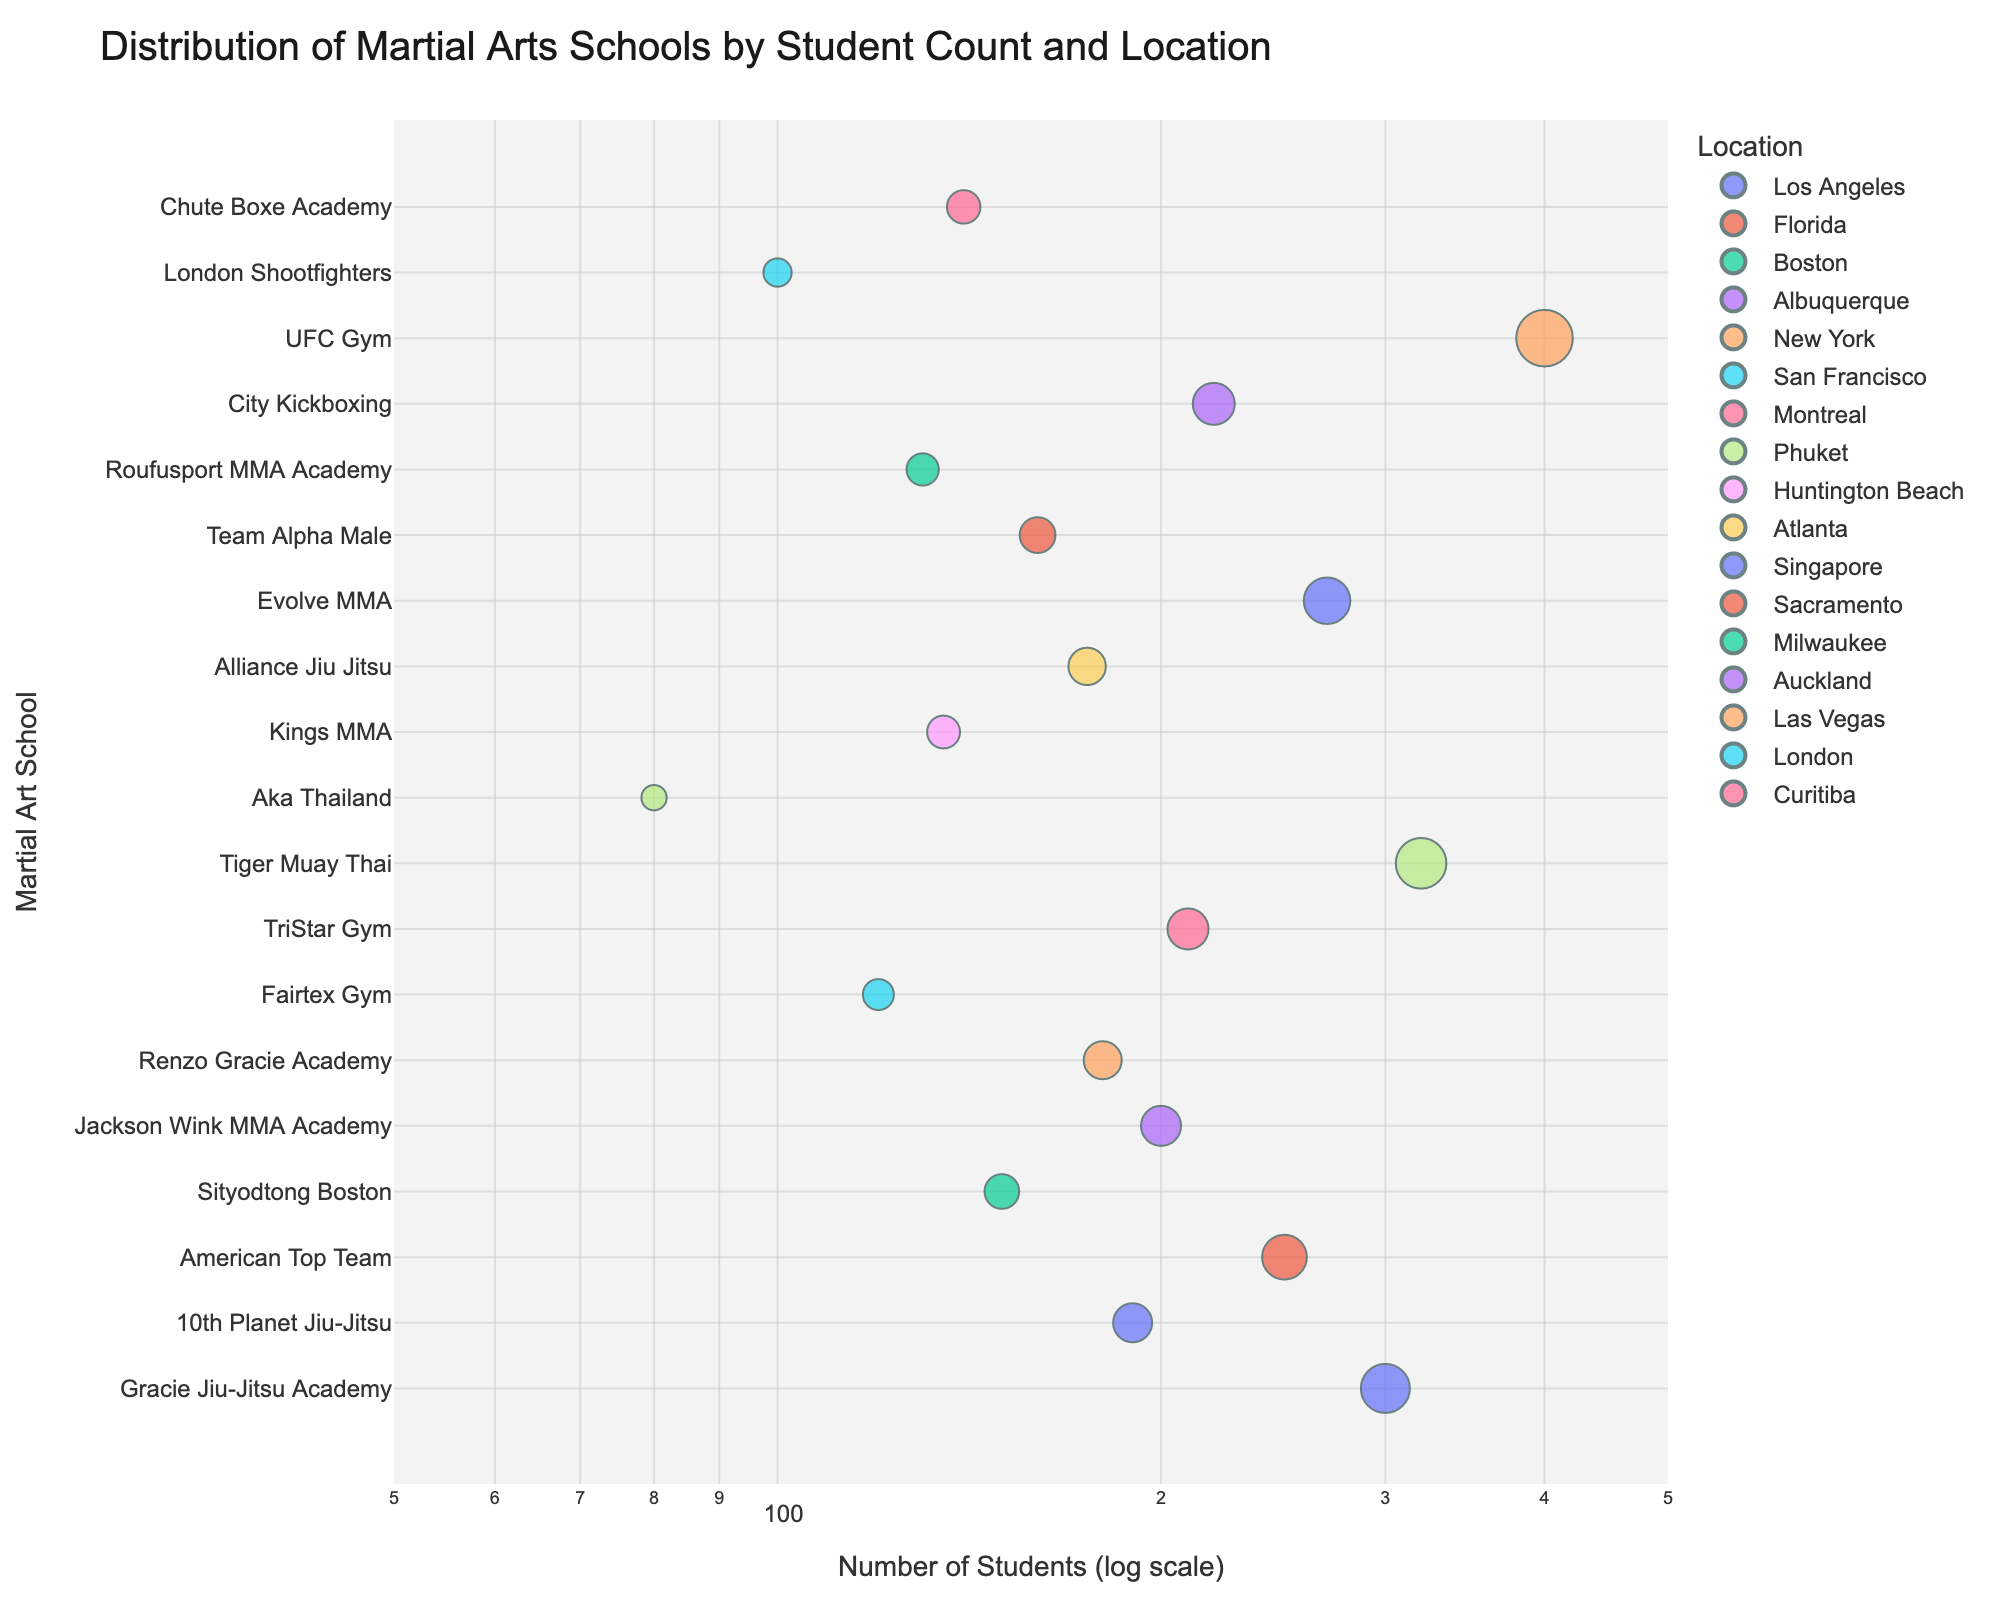What's the title of the scatter plot? The title is usually located at the top of a plot. By looking at the top, we can see the title displayed prominently.
Answer: Distribution of Martial Arts Schools by Student Count and Location What is the range of the x-axis representing the number of students? The range can be determined by looking at the beginning and end of the x-axis. The plot specifies a log scale with the range [1.7, 2.7]. This translates back to the values 10^1.7 ≈ 50 and 10^2.7 ≈ 500.
Answer: 50 to 500 What martial arts school has the smallest number of students? By examining the lowest point on the x-axis (farthest to the left), we find "Aka Thailand" at Phuket with only 80 students.
Answer: Aka Thailand Which martial arts school has the highest number of students and where is it located? By examining the scatter points on the far right of the x-axis, the school with the largest number of students is "UFC Gym" located in Las Vegas with 400 students.
Answer: UFC Gym, Las Vegas Which geographical region has the most popular martial arts schools (with the highest number of students overall)? To answer this, sum the number of students for each unique location and compare the totals. For instance, "Phuket" has Tiger Muay Thai (320) and Aka Thailand (80), which totals 400. Perform similar summations for other locations, e.g., Los Angeles (300 + 190 = 490). The highest total appears to be for Los Angeles.
Answer: Los Angeles Which school has more students: Renzo Gracie Academy or Alliance Jiu Jitsu? Compare the x-axis values for "Renzo Gracie Academy" and "Alliance Jiu Jitsu". Renzo Gracie Academy has 180 students, whereas Alliance Jiu Jitsu has 175.
Answer: Renzo Gracie Academy How many schools have more than 200 students? Identify all scatter points to the right of the 200 mark on the x-axis (log scale). These include "Gracie Jiu-Jitsu Academy" (300), "American Top Team" (250), "Tiger Muay Thai" (320), "Evolve MMA" (270), "TriStar Gym" (210), "City Kickboxing" (220), and "UFC Gym" (400). Count the number of these points.
Answer: 7 What's the average number of students for schools located in New York? Identify schools in New York and sum their student numbers. The only one in New York is "Renzo Gracie Academy" with 180 students. Since there's only one school listed in New York, the average is 180.
Answer: 180 Do more schools have student counts above or below 200? Count the schools with student counts above 200 and compare to those below. There are 7 schools above (already identified) and the rest (11) are below.
Answer: Below 200 